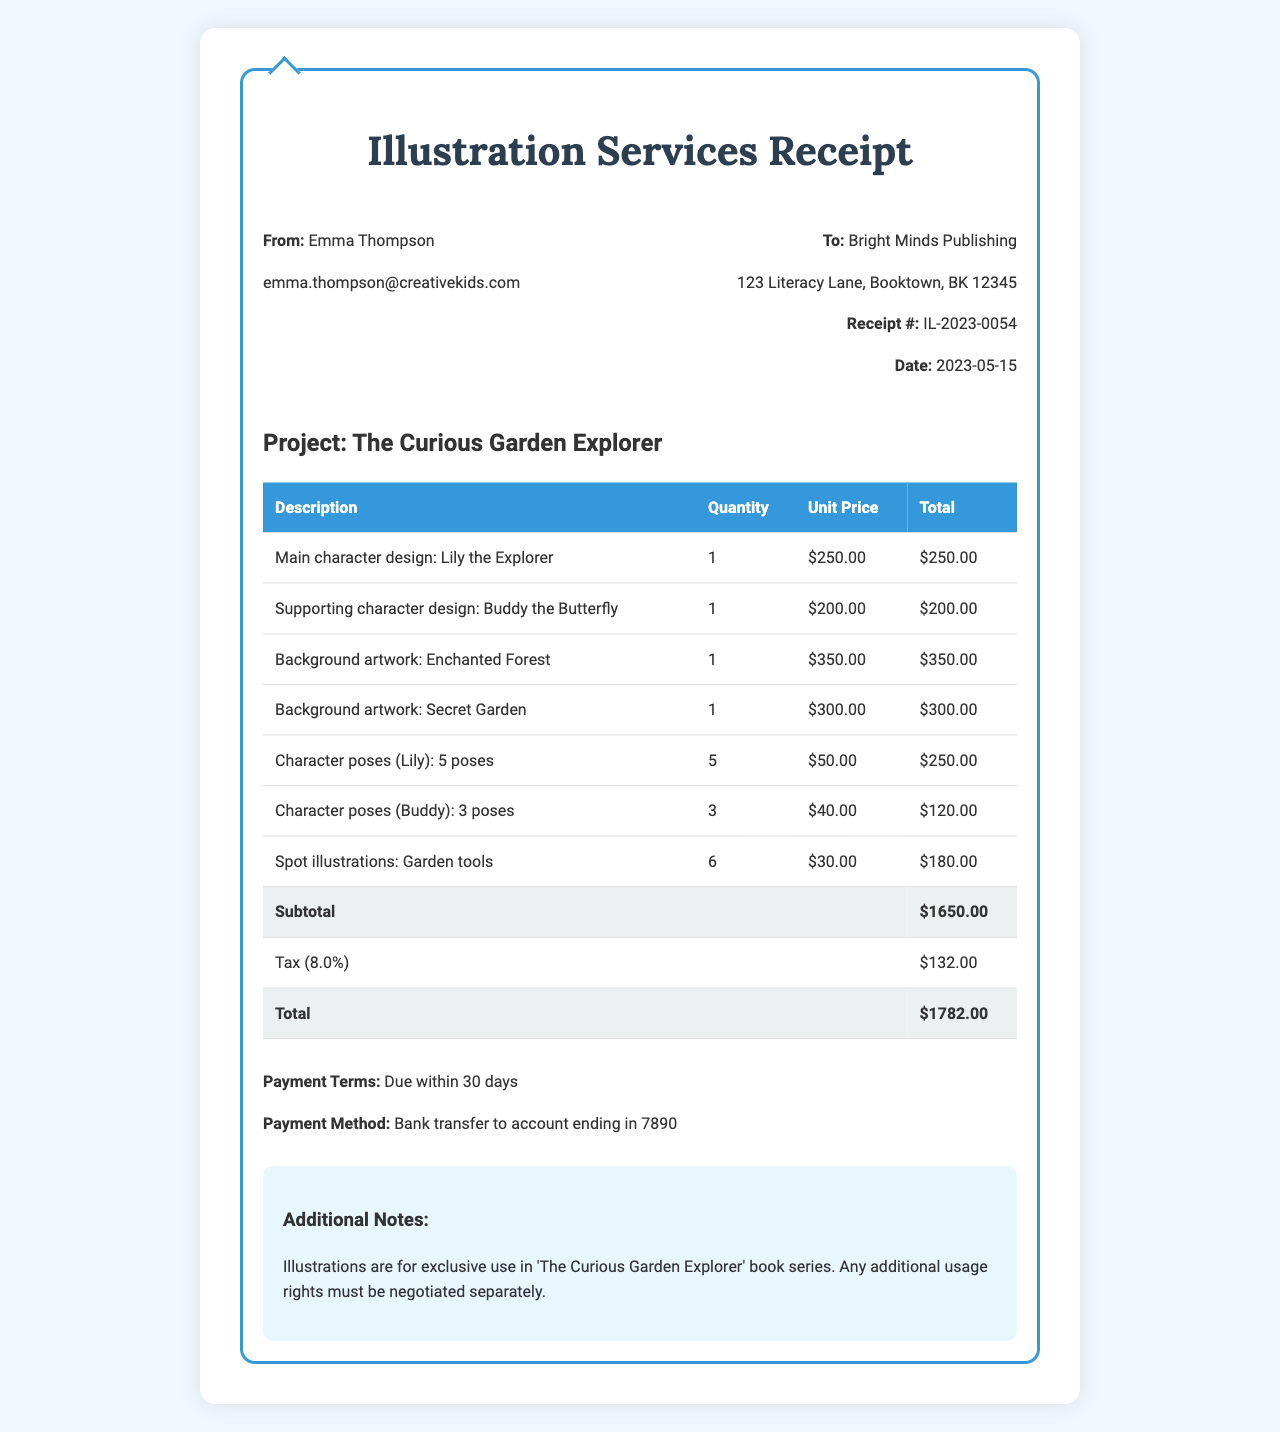What is the receipt number? The receipt number is found at the top of the document.
Answer: IL-2023-0054 Who is the illustrator? The name of the illustrator is provided in the document.
Answer: Emma Thompson What is the project title? The project title is listed prominently in the document.
Answer: The Curious Garden Explorer What is the total amount due? The total amount is the final figure listed in the summary section of the document.
Answer: 1782.00 How much is the unit price for the background artwork titled "Enchanted Forest"? The unit price for "Enchanted Forest" is specified under the services section.
Answer: 350.00 What is the tax rate applied? The tax rate is provided in the summary information of the document.
Answer: 8% How many character poses for "Lily" were created? The number of poses is stated in the services section of the document.
Answer: 5 What are the payment terms? The payment terms are included in the summary section of the document.
Answer: Due within 30 days What is the quantity of spot illustrations included? The quantity is specified in the services section of the document.
Answer: 6 